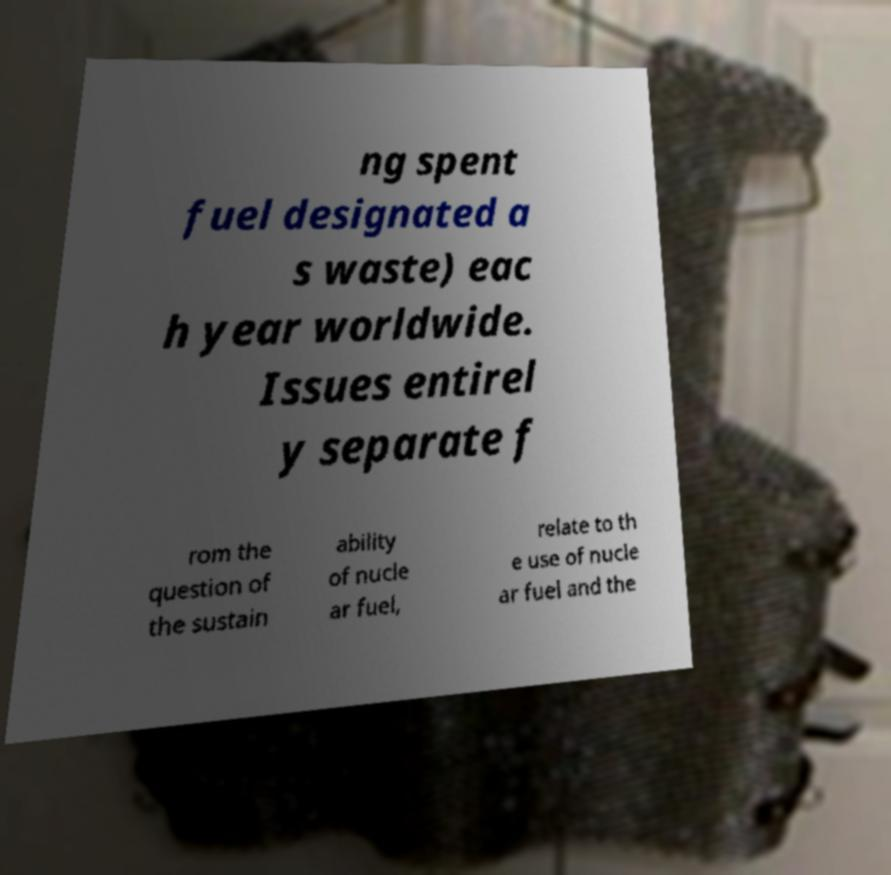Could you extract and type out the text from this image? ng spent fuel designated a s waste) eac h year worldwide. Issues entirel y separate f rom the question of the sustain ability of nucle ar fuel, relate to th e use of nucle ar fuel and the 